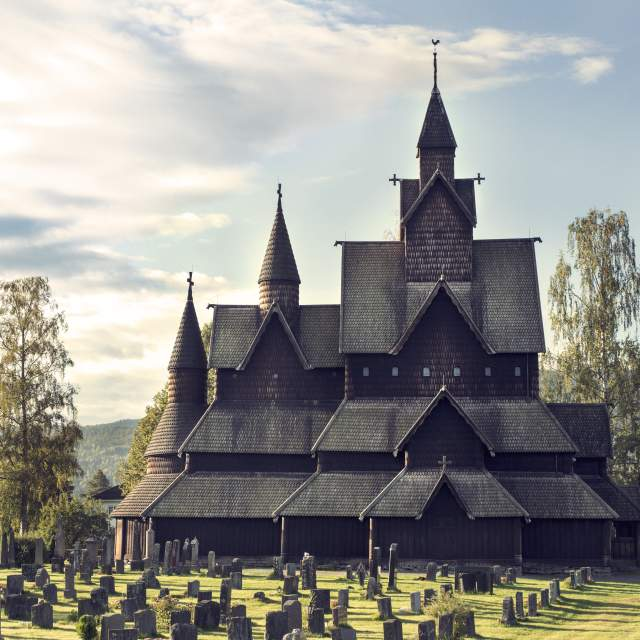If the church could speak, what stories would it tell? If Heddal Stave Church could speak, it would tell tales of centuries. It would recount the hands that shaped its wood, carving each detail with care. Stories of Viking times, when local chieftains perhaps offered prayers to both Christian and Norse gods within its walls. It would tell of medieval pilgrims seeking solace and the countless weddings, baptisms, and funerals marking the cycles of life for the community. In hushed tones, it might reveal the whispers and secrets shared in its holy halls, the laughter of children at play, and the solemn vows exchanged. The church would speak of resilience, having withstood the ravages of time, storms, and wars, standing as a testament to enduring faith and tradition. 